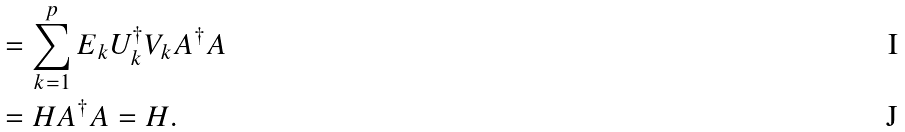Convert formula to latex. <formula><loc_0><loc_0><loc_500><loc_500>& = \sum _ { k = 1 } ^ { p } E _ { k } U _ { k } ^ { \dagger } V _ { k } A ^ { \dagger } A \\ & = H A ^ { \dagger } A = H .</formula> 